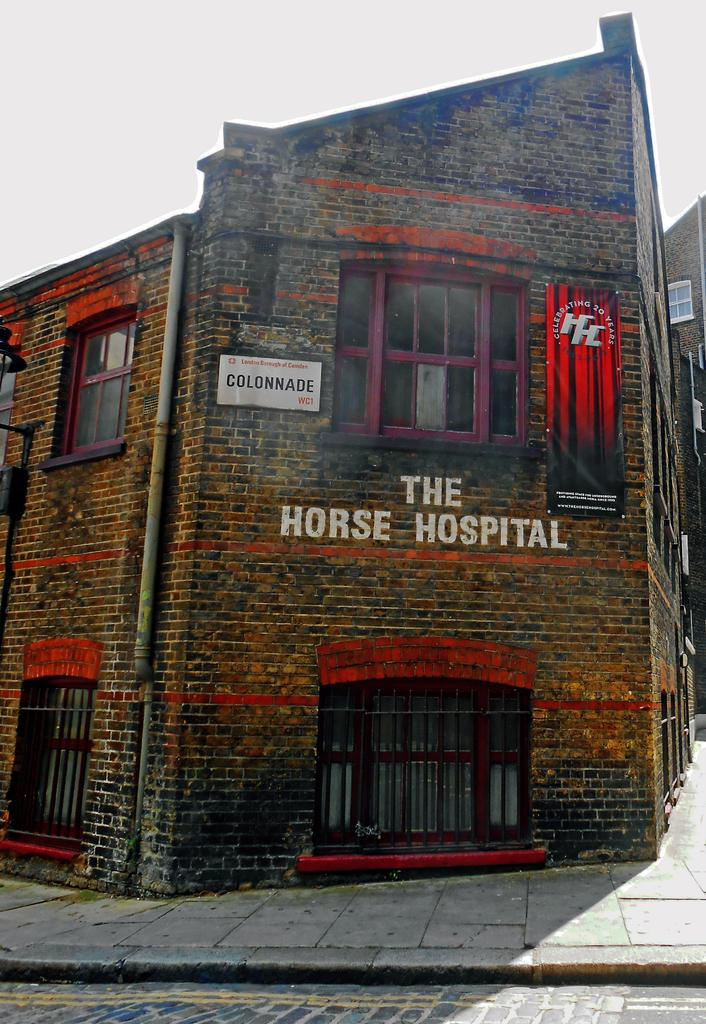What type of structure is present in the image? There is a building in the image. What features can be observed on the building? The building has windows, doors, and a brick wall. What additional objects are present in the image? There is a board, a banner, and a light in the image. What can be seen in the background of the image? The sky is visible in the background of the image. Can you tell me how many lawyers are depicted on the board in the image? There are no lawyers present in the image, as the board does not depict any people or professions. Is there a bat flying in the sky in the image? There is no bat visible in the sky in the image. 